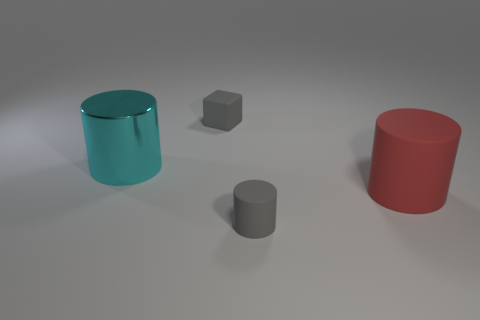Add 3 small blue matte cylinders. How many objects exist? 7 Subtract all large red cylinders. How many cylinders are left? 2 Subtract all green spheres. How many cyan cylinders are left? 1 Subtract all gray cylinders. How many cylinders are left? 2 Subtract 1 gray cylinders. How many objects are left? 3 Subtract all cylinders. How many objects are left? 1 Subtract 1 cylinders. How many cylinders are left? 2 Subtract all cyan cylinders. Subtract all gray balls. How many cylinders are left? 2 Subtract all gray rubber cubes. Subtract all big cyan things. How many objects are left? 2 Add 1 big cyan cylinders. How many big cyan cylinders are left? 2 